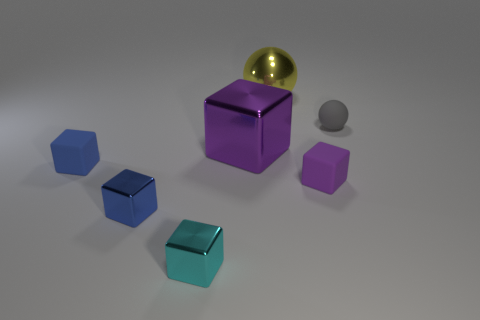Are there any objects in front of the tiny blue rubber block?
Keep it short and to the point. Yes. There is a large metallic object that is in front of the tiny matte object behind the large object in front of the matte sphere; what color is it?
Give a very brief answer. Purple. There is a thing that is the same size as the shiny sphere; what shape is it?
Make the answer very short. Cube. Is the number of purple shiny blocks greater than the number of small brown cylinders?
Give a very brief answer. Yes. Are there any cubes left of the cube on the right side of the yellow sphere?
Offer a very short reply. Yes. There is another big thing that is the same shape as the cyan metallic object; what is its color?
Provide a succinct answer. Purple. There is another large block that is made of the same material as the cyan cube; what is its color?
Your answer should be compact. Purple. There is a tiny matte object that is behind the large metallic thing that is in front of the tiny gray object; is there a large block in front of it?
Make the answer very short. Yes. Is the number of blocks to the right of the large purple metal object less than the number of spheres that are behind the tiny purple thing?
Offer a very short reply. Yes. What number of small cyan things have the same material as the big block?
Make the answer very short. 1. 